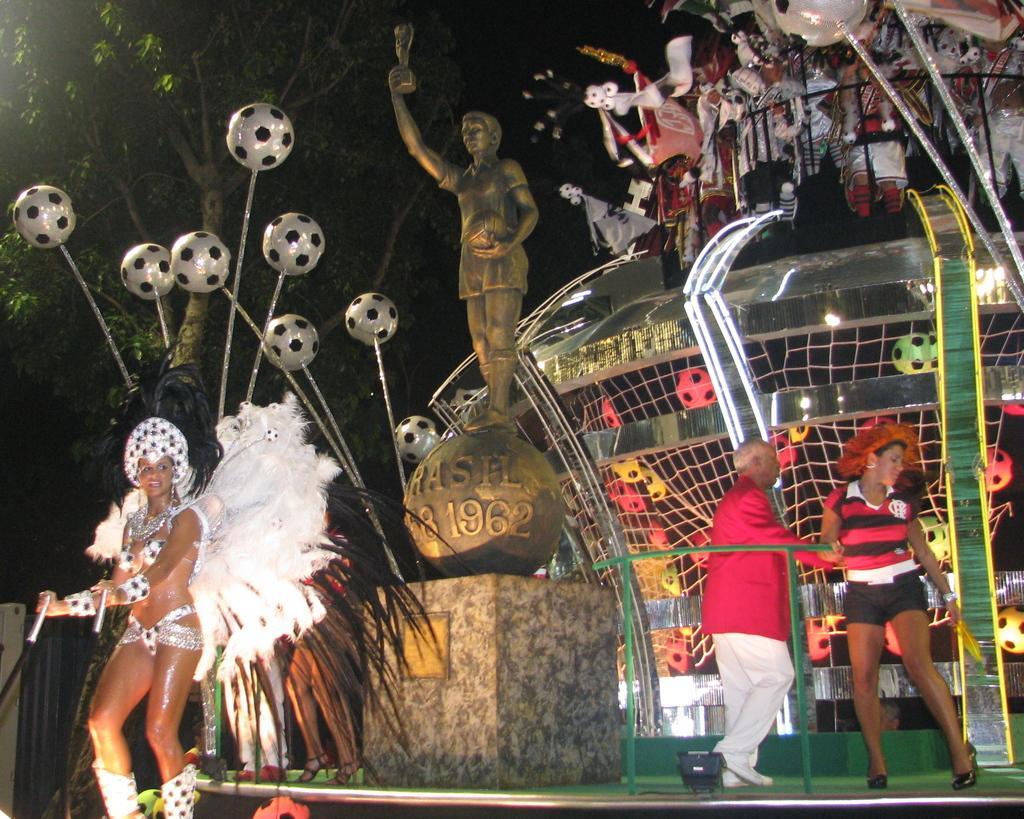Describe this image in one or two sentences. There are people in the foreground area of the image, there are balls, it seems like toys, sculpture, other objects and a tree in the background. 